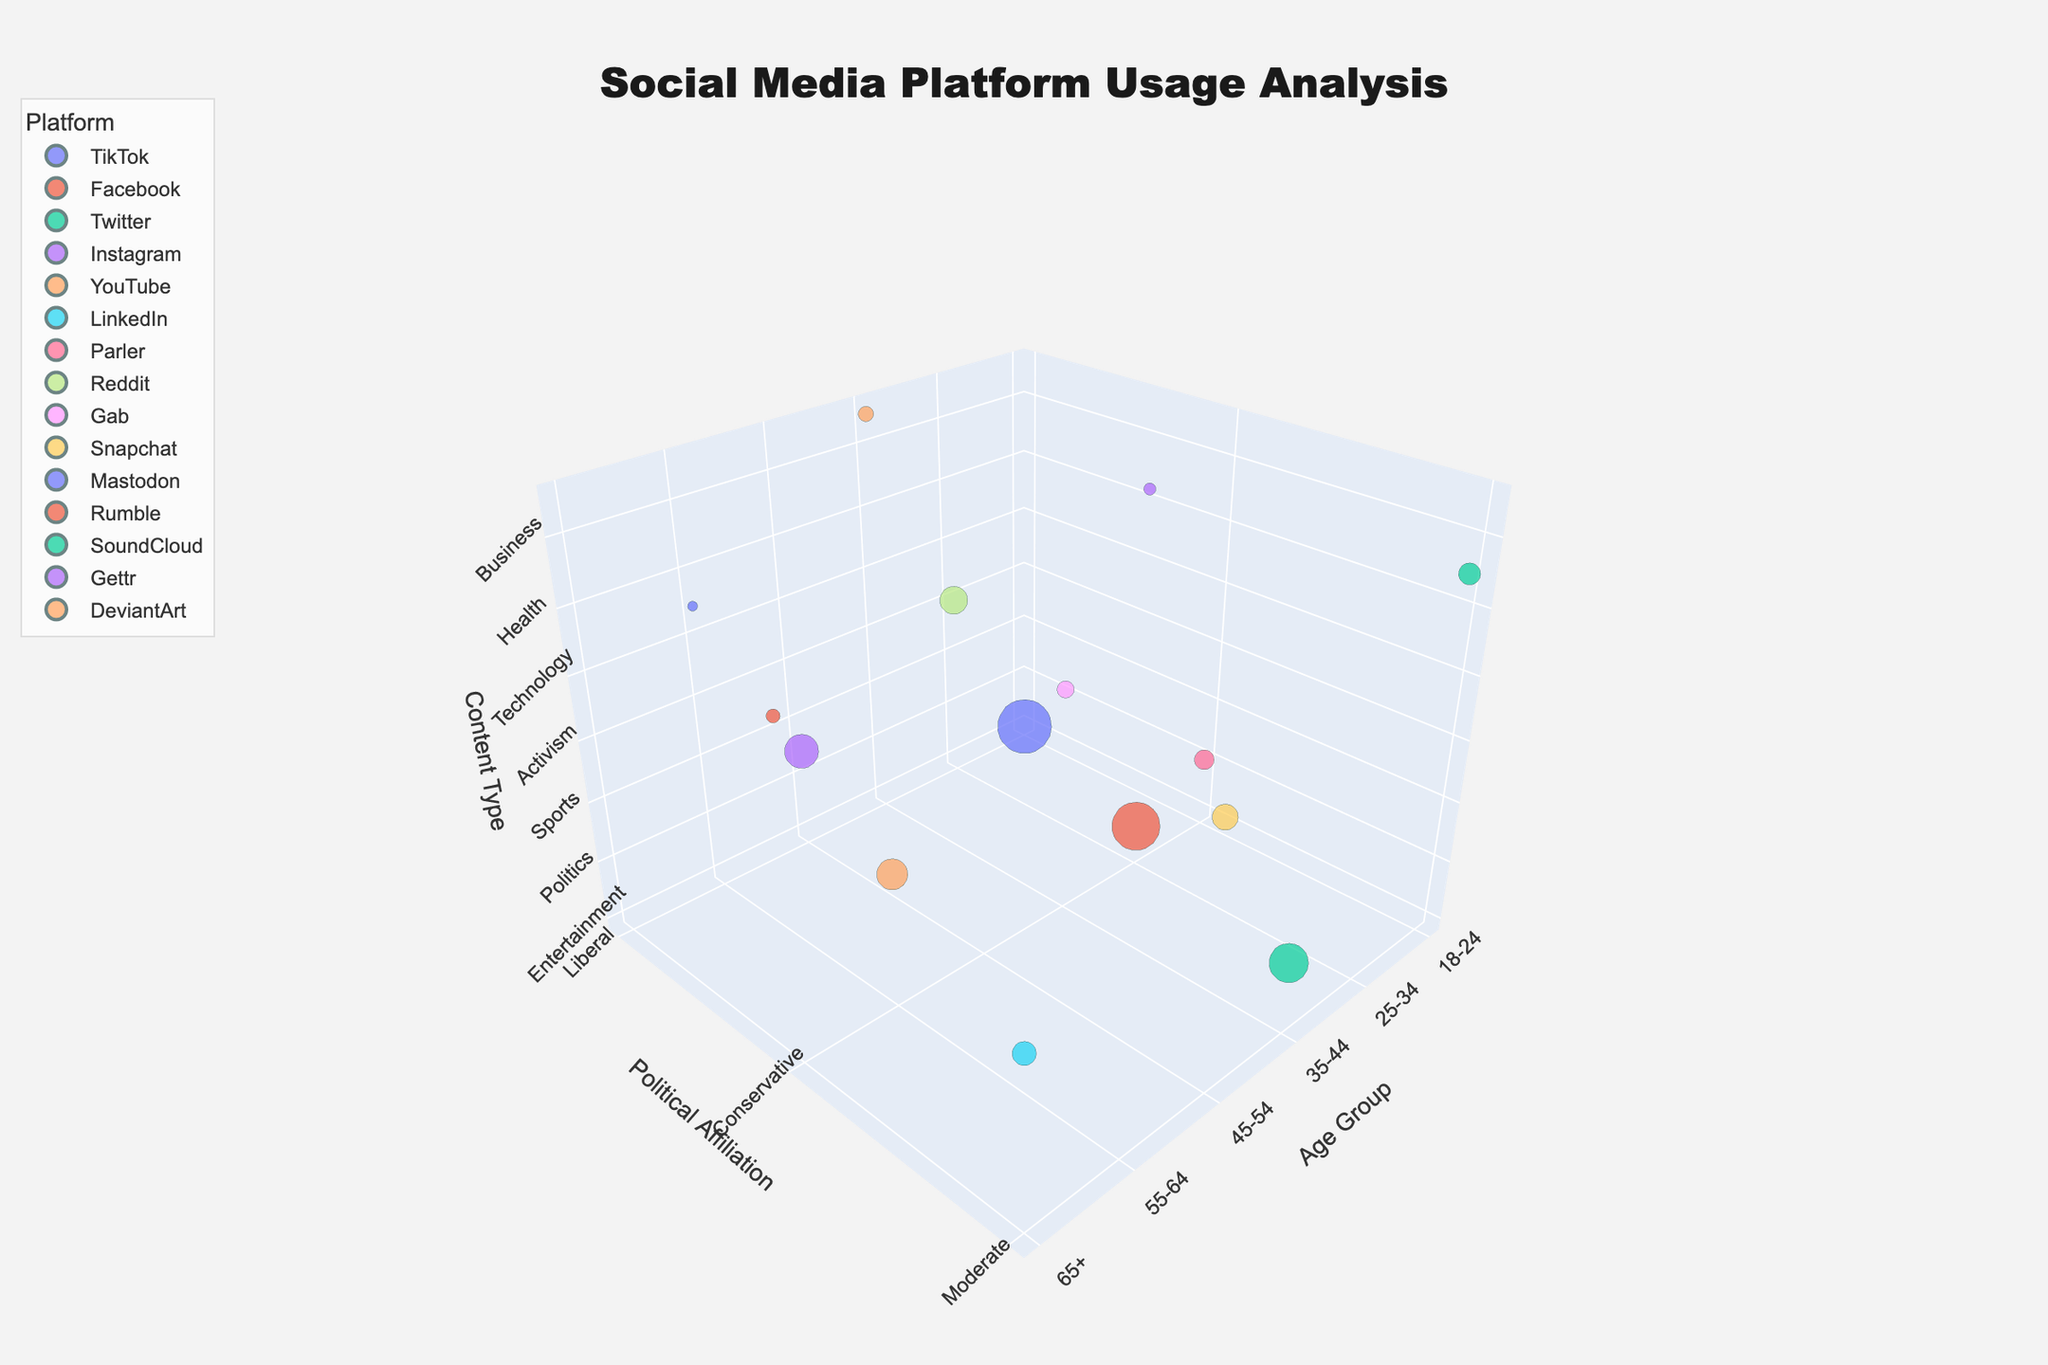What is the title of the figure? The title is displayed at the top of the chart and it reads: "Social Media Platform Usage Analysis"
Answer: Social Media Platform Usage Analysis What does the size of the bubbles represent in the chart? The chart uses bubble sizes to represent the number of users for each platform, as indicated by the "Users" data. Larger bubbles mean more users.
Answer: Number of Users Which social media platform has the largest bubble for the 18-24 age group? Locate the bubbles on the chart for the 18-24 age group and identify the one with the largest size. The largest bubble in this age group is for TikTok.
Answer: TikTok Compare the number of users on Parler vs. Gettr. Which one has more users? Locate the bubbles for Parler and Gettr and compare their sizes. Parler has a bigger bubble size with 2,000,000 users compared to Gettr's 750,000 users.
Answer: Parler How many platforms have bubbles in the 'Liberal' category? Count the bubbles in the 'Liberal' category on the vertical 'Political Affiliation' axis. There are four platforms: TikTok, Instagram, Reddit, and Mastodon.
Answer: Four What is the total number of users for all Conservative platforms in the 25-34 age group? Identify all Conservative bubbles for the 25-34 age group: Facebook and Gettr. Sum their users: 12,000,000 (Facebook) + 750,000 (Gettr) = 12,750,000.
Answer: 12,750,000 What content type is represented by the smallest bubble for the 45-54 age group? Locate the 45-54 age group section and identify the smallest bubble. The smallest bubble represents Snapchat with Technology content type.
Answer: Technology Which platform in the 'Moderate' political category has the highest number of users? Locate the Moderate bubbles and compare their sizes. LinkedIn for Education content type has the highest number of users with 3,000,000.
Answer: LinkedIn Compare the Facebook and YouTube bubbles. Which age group uses these platforms the most? Look for the largest bubbles for Facebook and YouTube. Facebook's largest bubble is in the 25-34 age group, and YouTube's largest bubble is in the 55-64 age group.
Answer: Facebook: 25-34, YouTube: 55-64 How many platforms target 'Entertainment' content and for which age groups? Find the 'Entertainment' content bubbles and identify their age groups. There is one platform, TikTok, targeting the 18-24 age group.
Answer: One platform, 18-24 age group 